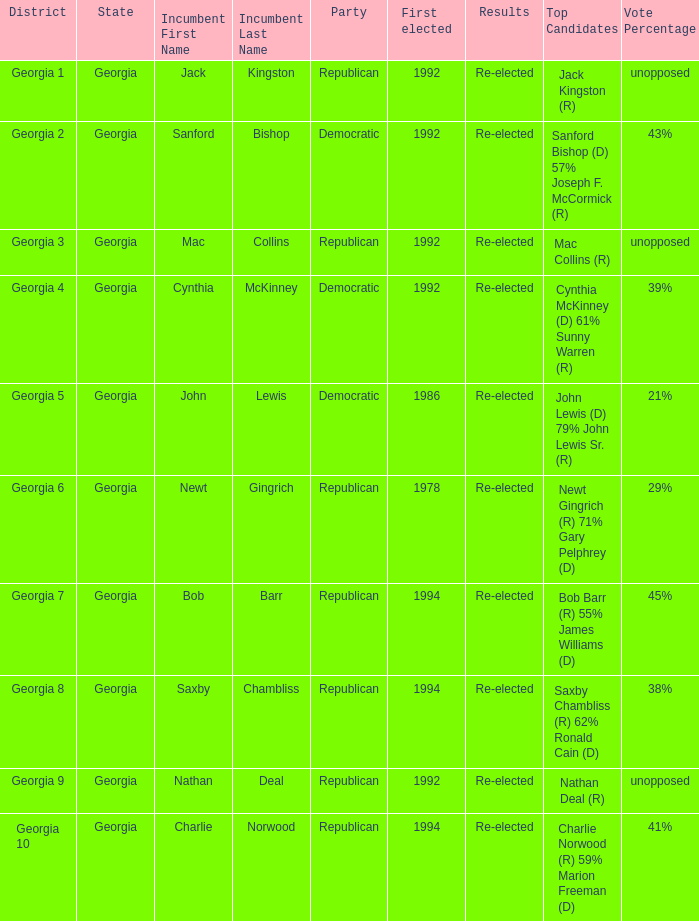Who were the candidates in the election where Saxby Chambliss was the incumbent? Saxby Chambliss (R) 62% Ronald Cain (D) 38%. 